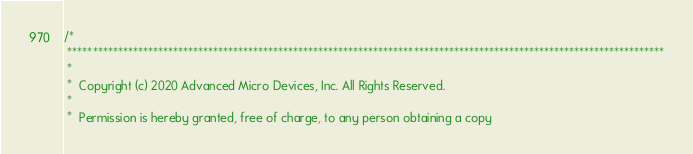Convert code to text. <code><loc_0><loc_0><loc_500><loc_500><_C_>/*
 ***********************************************************************************************************************
 *
 *  Copyright (c) 2020 Advanced Micro Devices, Inc. All Rights Reserved.
 *
 *  Permission is hereby granted, free of charge, to any person obtaining a copy</code> 